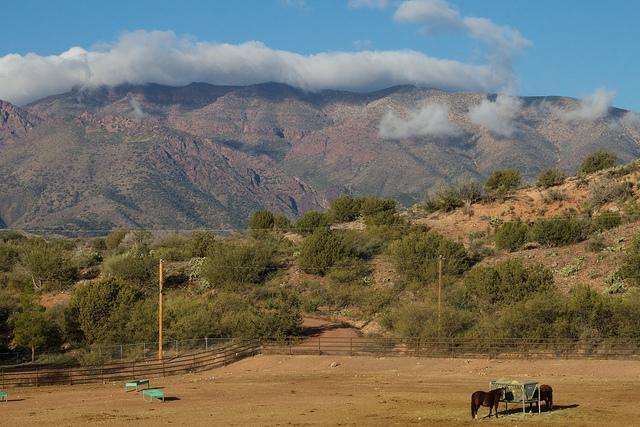How many people are wearing white pants?
Give a very brief answer. 0. 